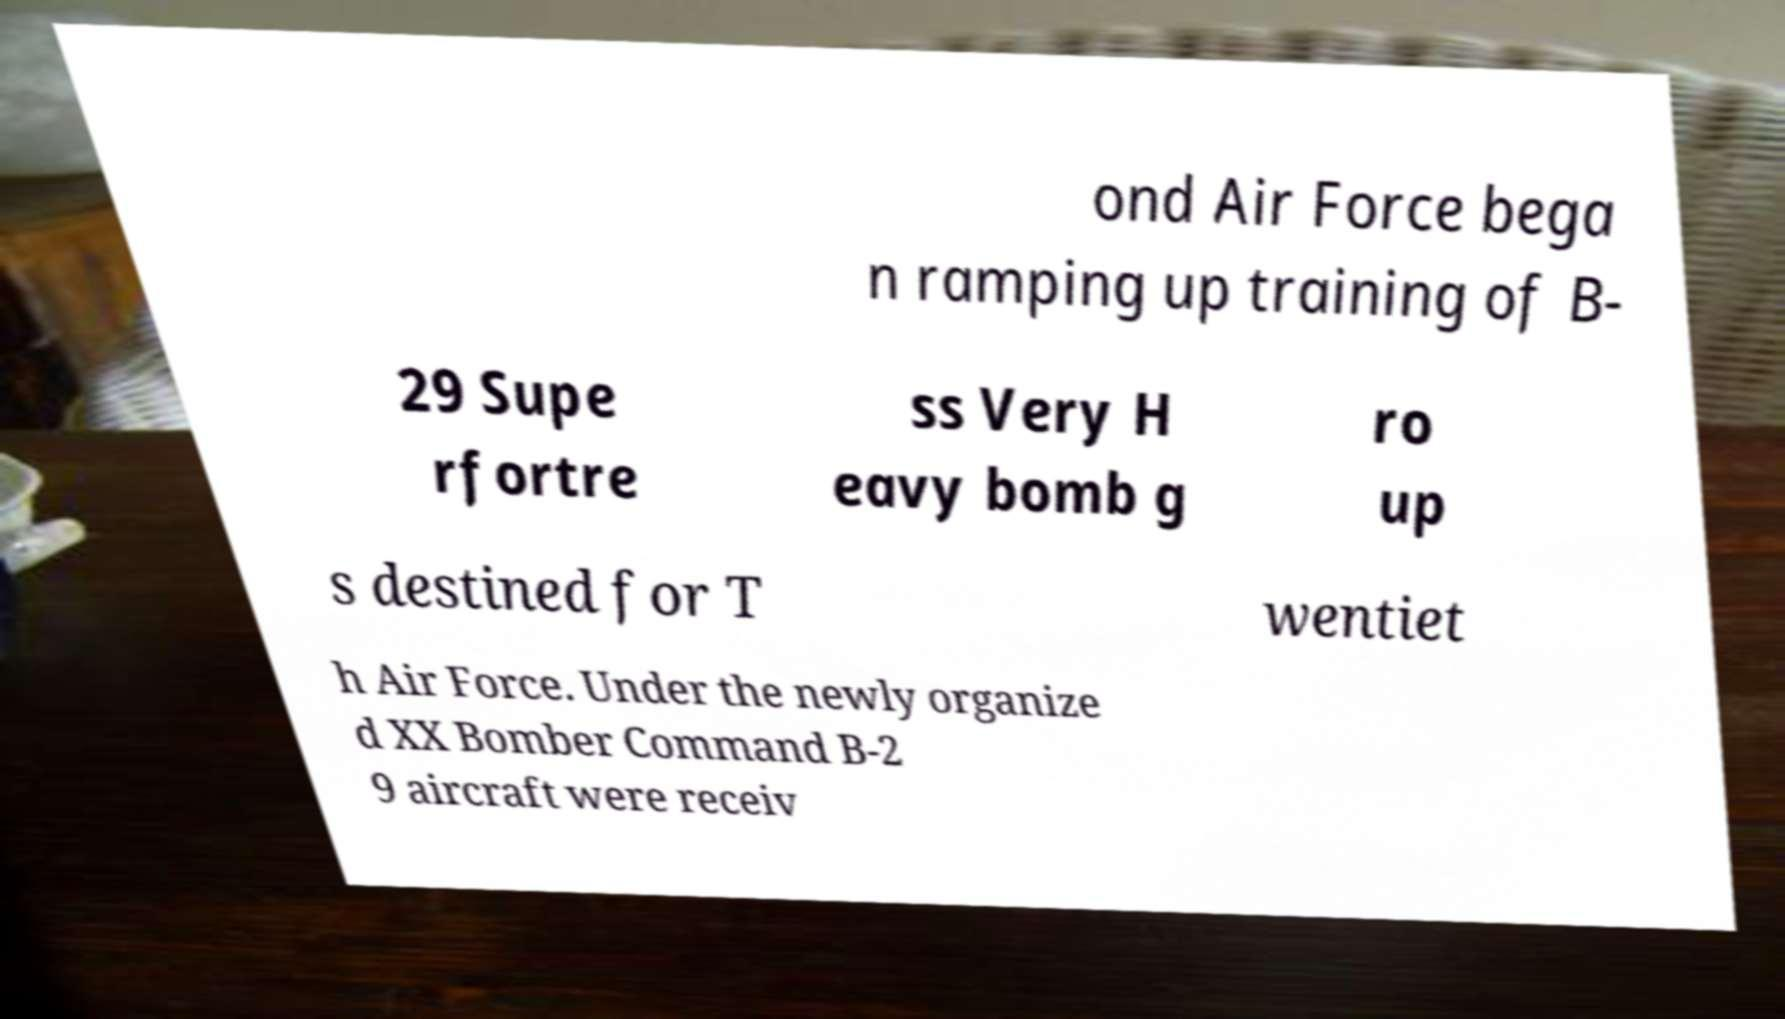I need the written content from this picture converted into text. Can you do that? ond Air Force bega n ramping up training of B- 29 Supe rfortre ss Very H eavy bomb g ro up s destined for T wentiet h Air Force. Under the newly organize d XX Bomber Command B-2 9 aircraft were receiv 